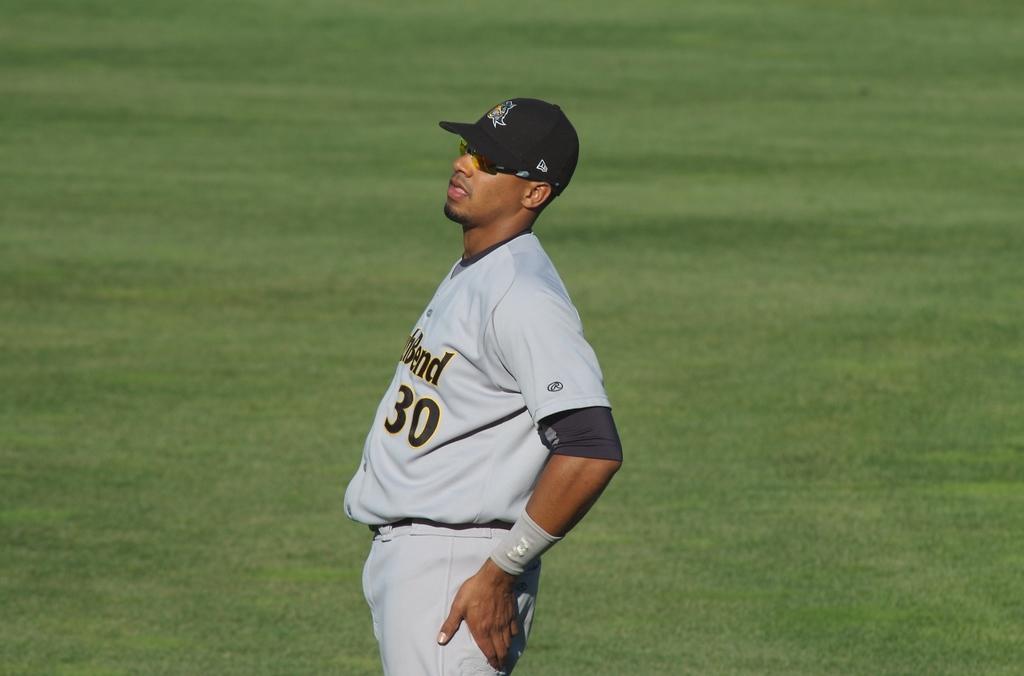What letter does his team's name end in?
Give a very brief answer. D. 